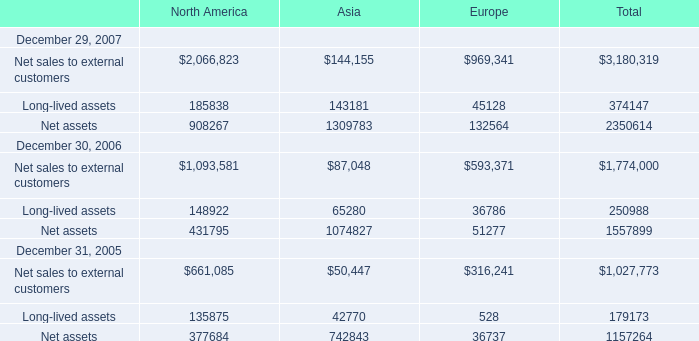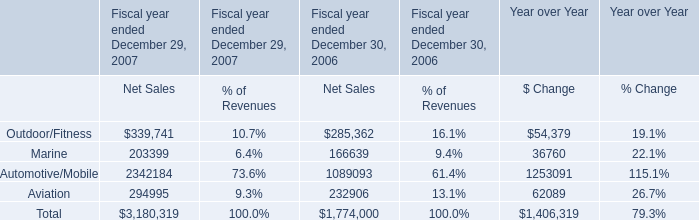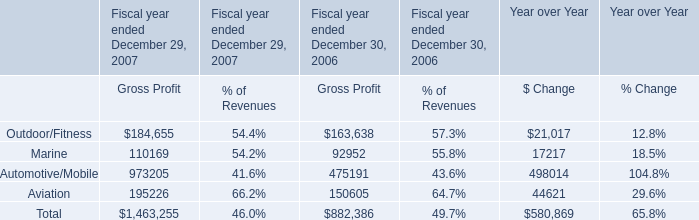What's the 70% of total elements for Asia in 2006? 
Computations: (((87048 + 65280) + 1074827) * 0.7)
Answer: 859008.5. 